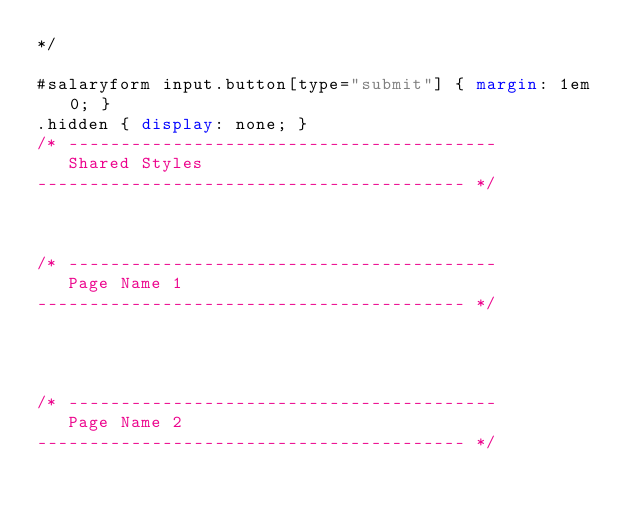Convert code to text. <code><loc_0><loc_0><loc_500><loc_500><_CSS_>*/

#salaryform input.button[type="submit"] { margin: 1em 0; }
.hidden { display: none; }
/* -----------------------------------------
   Shared Styles
----------------------------------------- */



/* -----------------------------------------
   Page Name 1
----------------------------------------- */




/* -----------------------------------------
   Page Name 2
----------------------------------------- */


</code> 